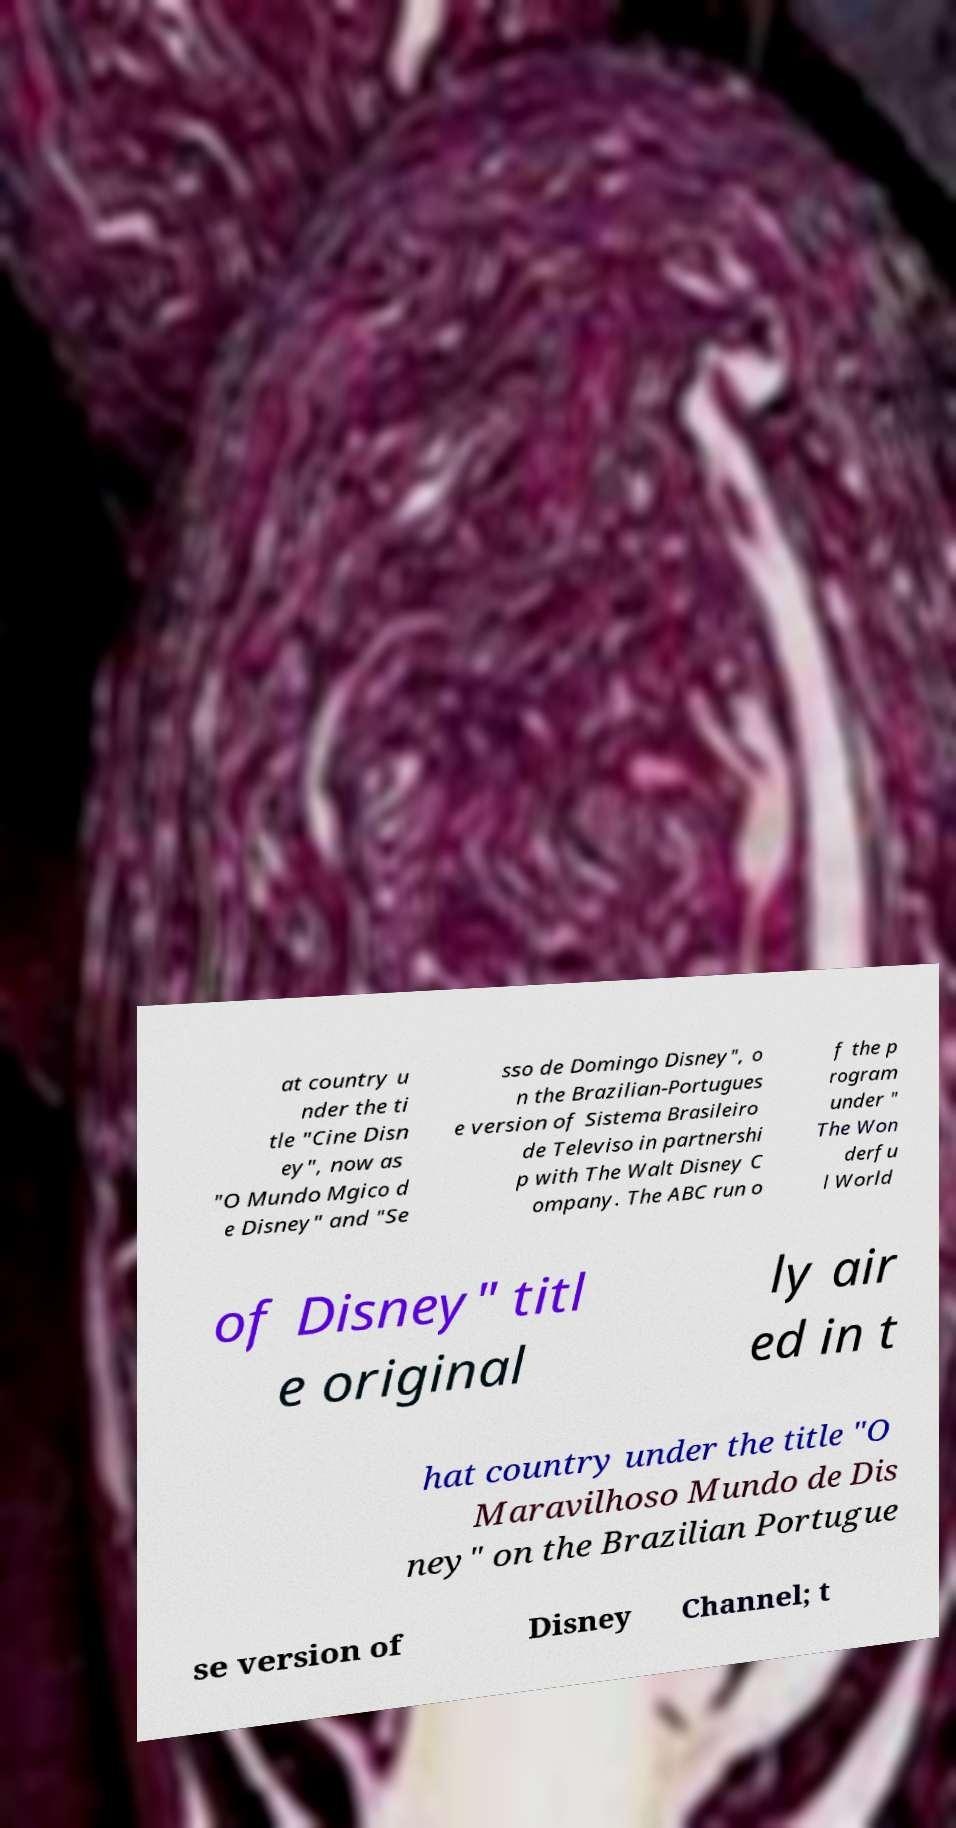Please read and relay the text visible in this image. What does it say? at country u nder the ti tle "Cine Disn ey", now as "O Mundo Mgico d e Disney" and "Se sso de Domingo Disney", o n the Brazilian-Portugues e version of Sistema Brasileiro de Televiso in partnershi p with The Walt Disney C ompany. The ABC run o f the p rogram under " The Won derfu l World of Disney" titl e original ly air ed in t hat country under the title "O Maravilhoso Mundo de Dis ney" on the Brazilian Portugue se version of Disney Channel; t 